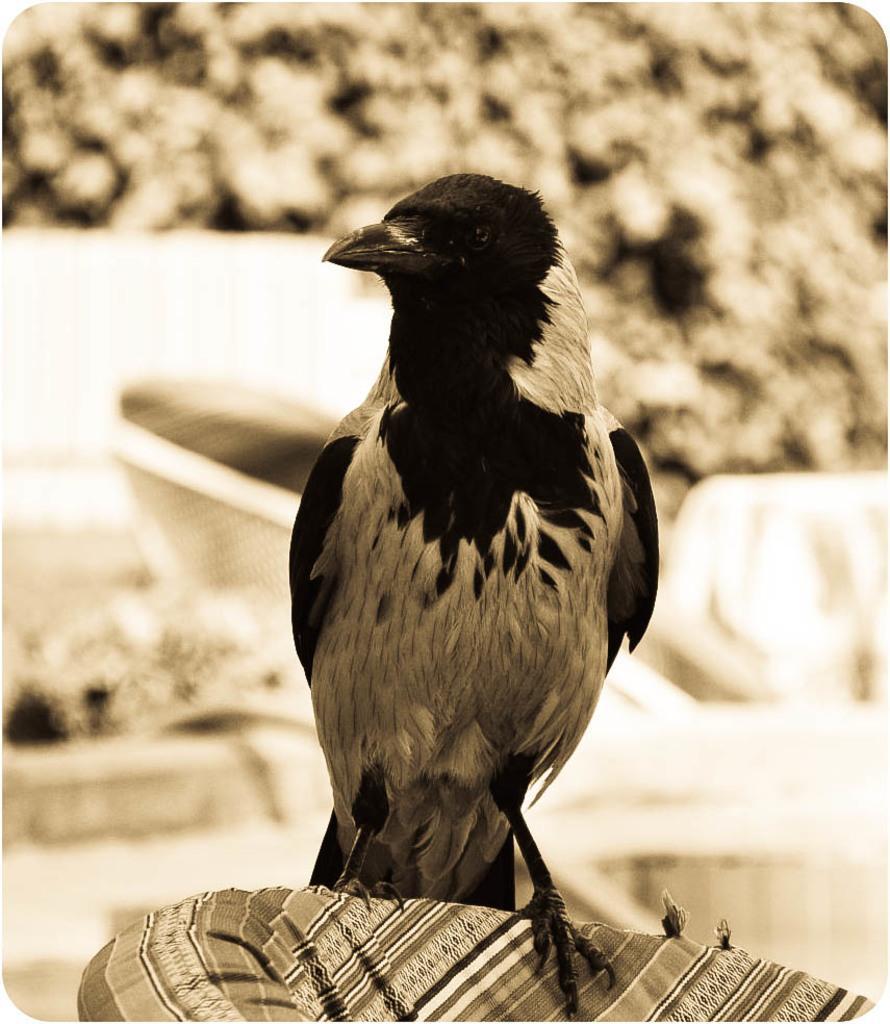Could you give a brief overview of what you see in this image? I see that this image is of brown and white in color and I see that there is a bird over here which is of black and brown in color and it is on a cloth and I see that it is blurred in the background. 